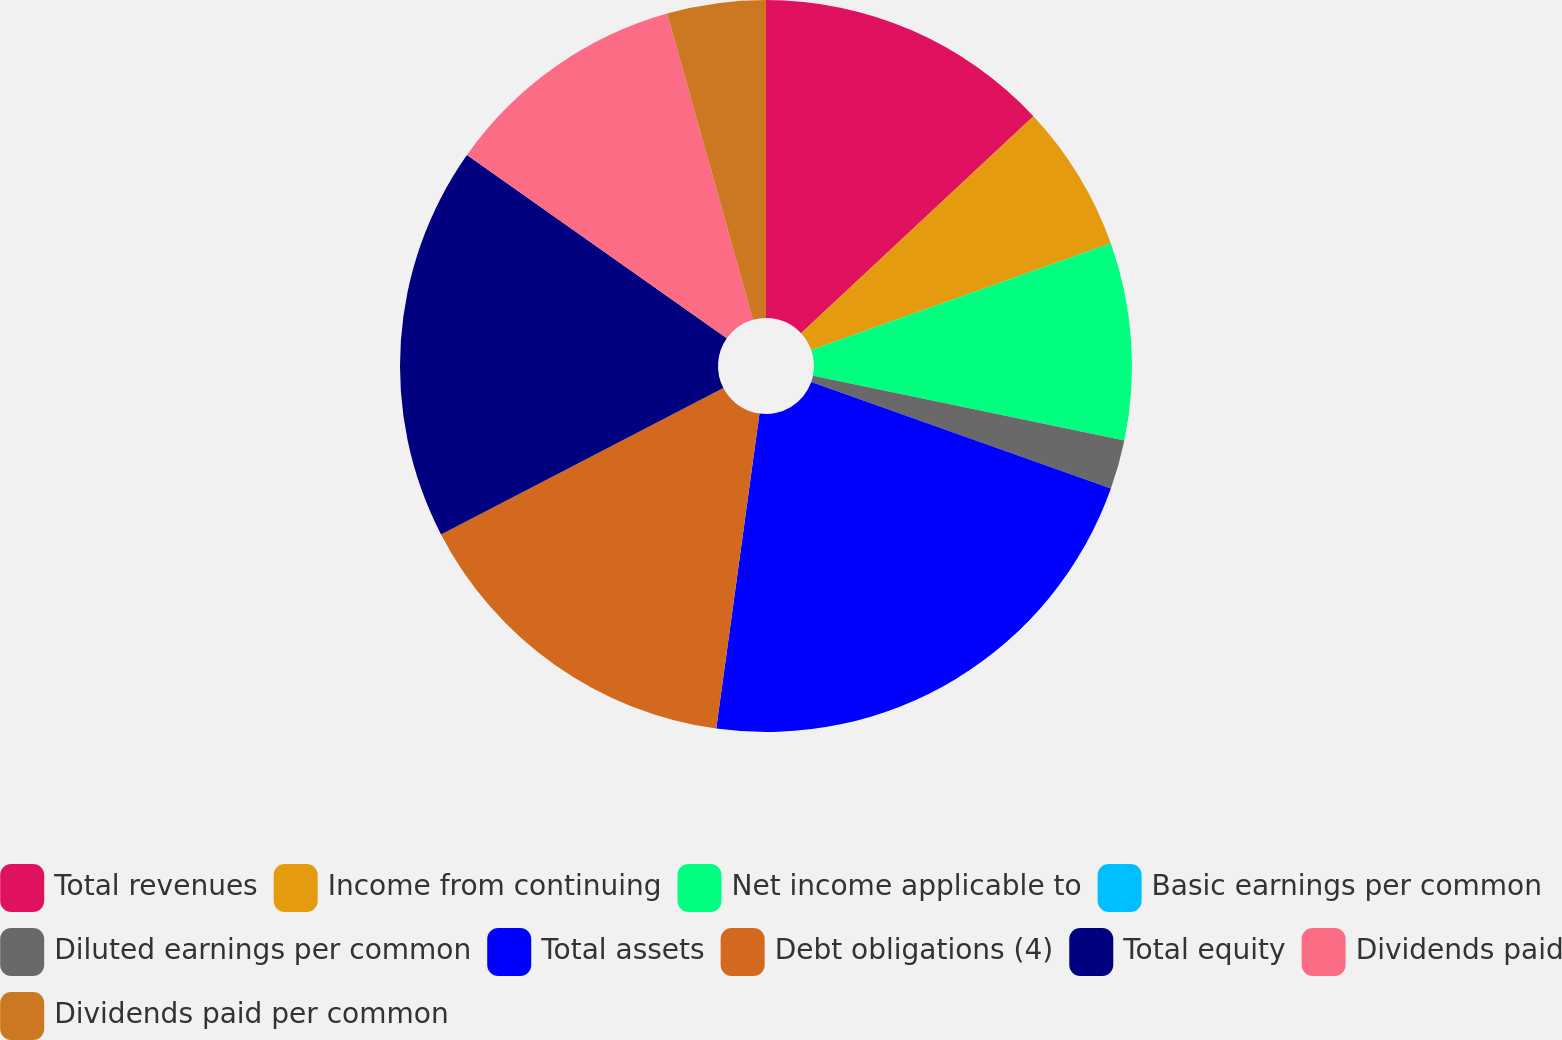<chart> <loc_0><loc_0><loc_500><loc_500><pie_chart><fcel>Total revenues<fcel>Income from continuing<fcel>Net income applicable to<fcel>Basic earnings per common<fcel>Diluted earnings per common<fcel>Total assets<fcel>Debt obligations (4)<fcel>Total equity<fcel>Dividends paid<fcel>Dividends paid per common<nl><fcel>13.04%<fcel>6.52%<fcel>8.7%<fcel>0.0%<fcel>2.17%<fcel>21.74%<fcel>15.22%<fcel>17.39%<fcel>10.87%<fcel>4.35%<nl></chart> 